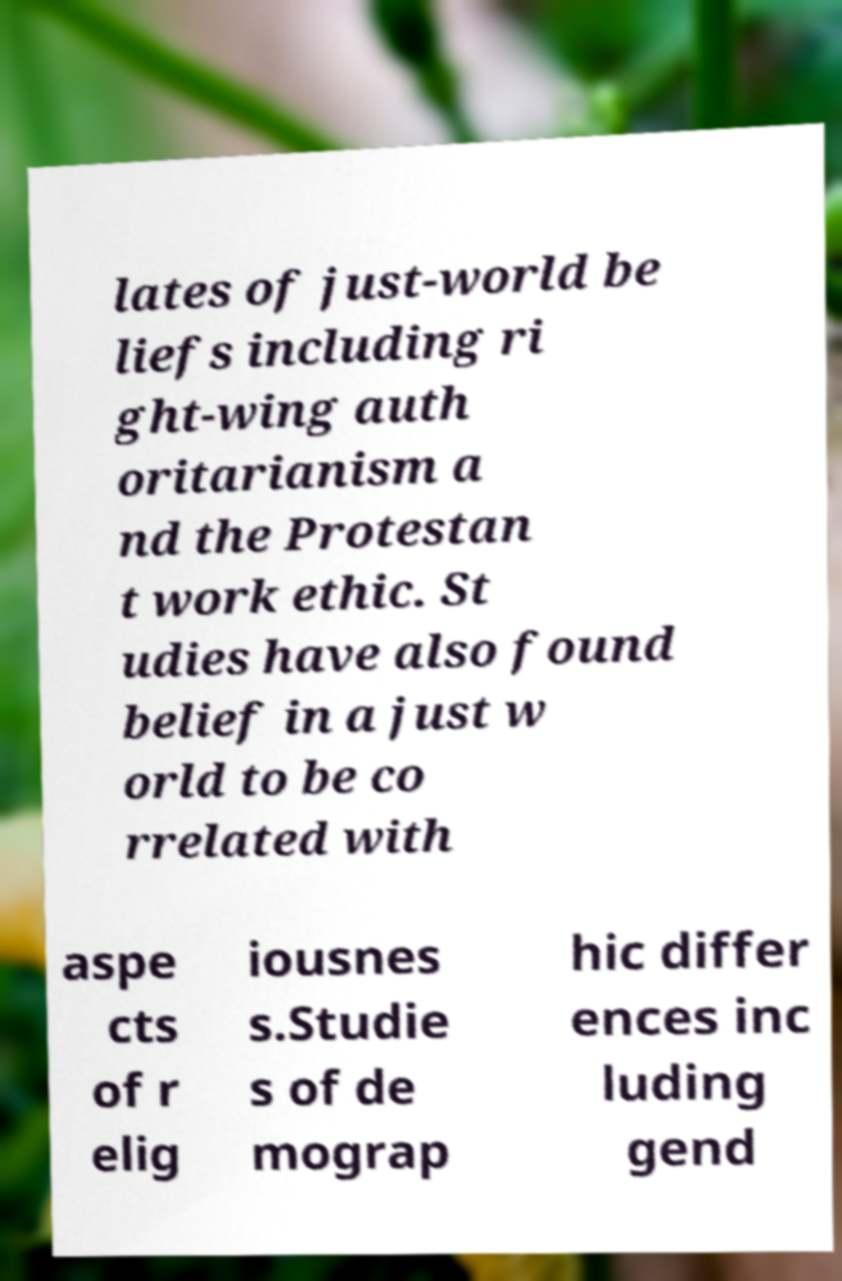I need the written content from this picture converted into text. Can you do that? lates of just-world be liefs including ri ght-wing auth oritarianism a nd the Protestan t work ethic. St udies have also found belief in a just w orld to be co rrelated with aspe cts of r elig iousnes s.Studie s of de mograp hic differ ences inc luding gend 